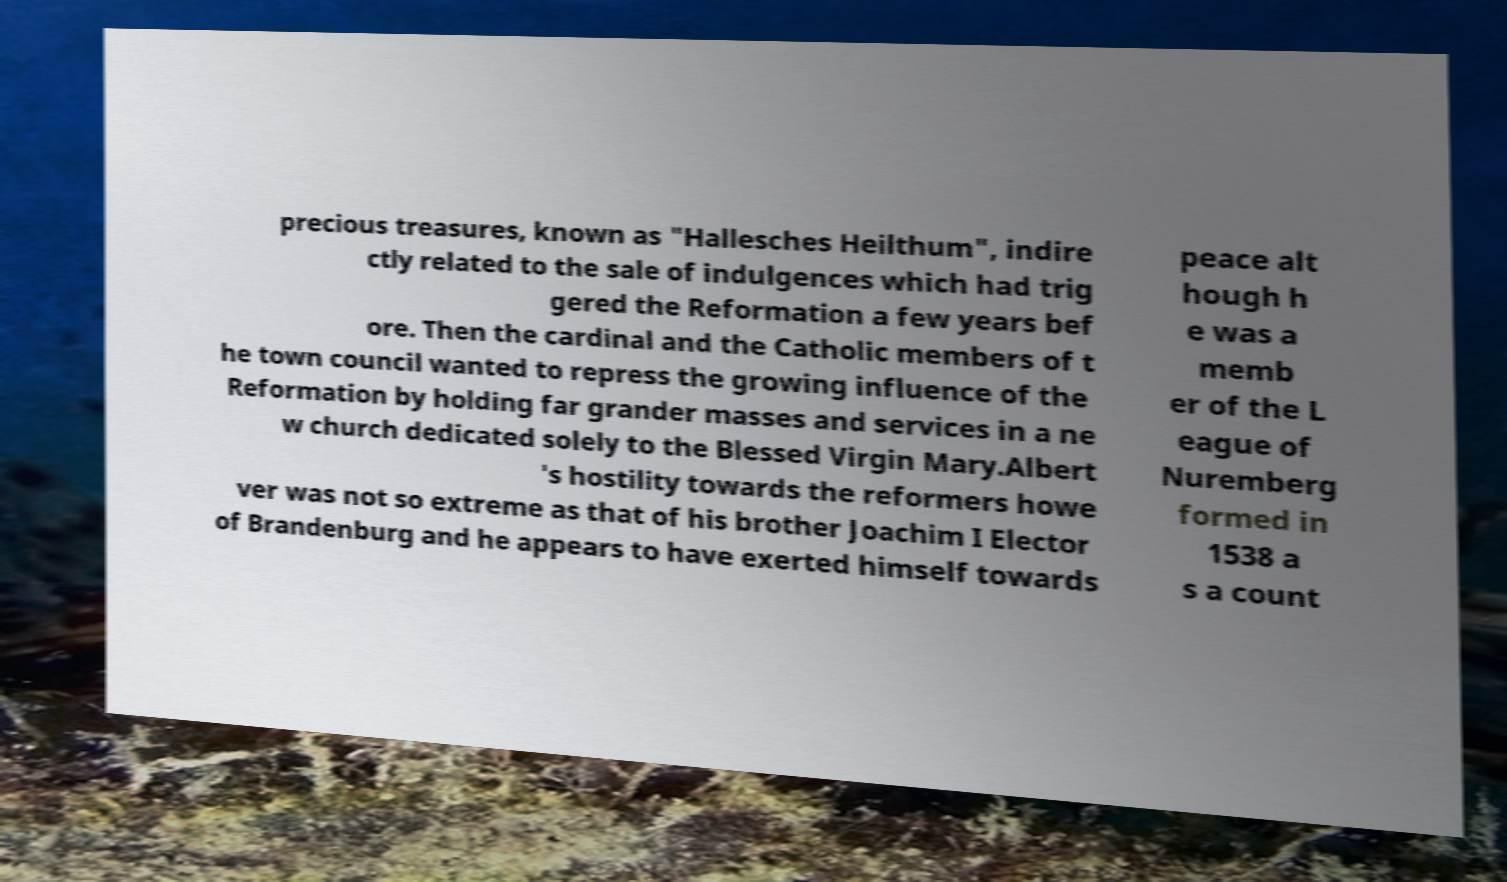There's text embedded in this image that I need extracted. Can you transcribe it verbatim? precious treasures, known as "Hallesches Heilthum", indire ctly related to the sale of indulgences which had trig gered the Reformation a few years bef ore. Then the cardinal and the Catholic members of t he town council wanted to repress the growing influence of the Reformation by holding far grander masses and services in a ne w church dedicated solely to the Blessed Virgin Mary.Albert 's hostility towards the reformers howe ver was not so extreme as that of his brother Joachim I Elector of Brandenburg and he appears to have exerted himself towards peace alt hough h e was a memb er of the L eague of Nuremberg formed in 1538 a s a count 